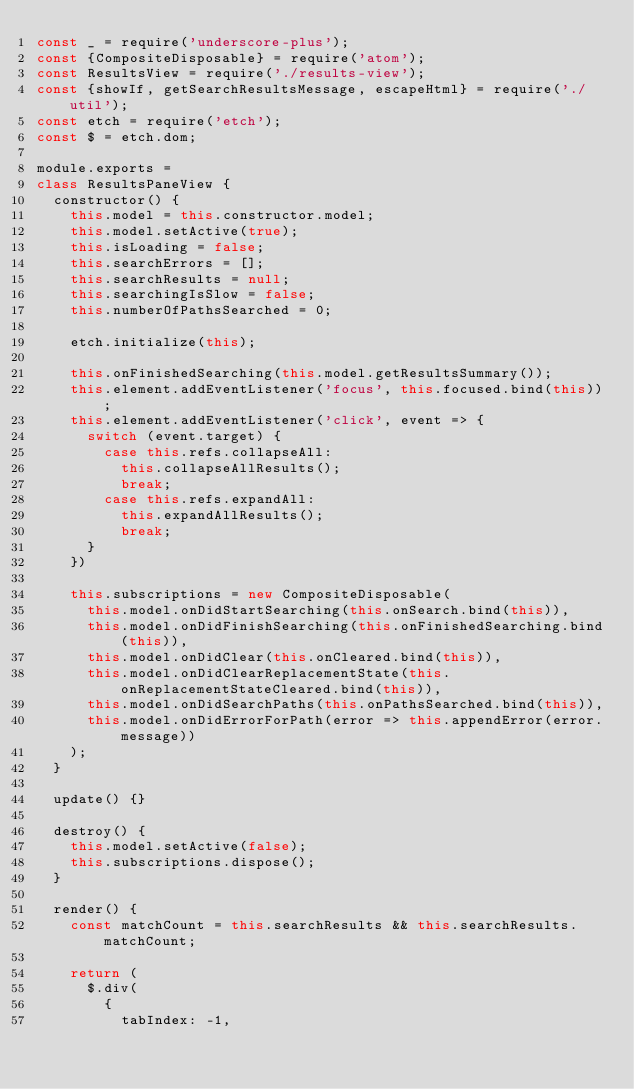Convert code to text. <code><loc_0><loc_0><loc_500><loc_500><_JavaScript_>const _ = require('underscore-plus');
const {CompositeDisposable} = require('atom');
const ResultsView = require('./results-view');
const {showIf, getSearchResultsMessage, escapeHtml} = require('./util');
const etch = require('etch');
const $ = etch.dom;

module.exports =
class ResultsPaneView {
  constructor() {
    this.model = this.constructor.model;
    this.model.setActive(true);
    this.isLoading = false;
    this.searchErrors = [];
    this.searchResults = null;
    this.searchingIsSlow = false;
    this.numberOfPathsSearched = 0;

    etch.initialize(this);

    this.onFinishedSearching(this.model.getResultsSummary());
    this.element.addEventListener('focus', this.focused.bind(this));
    this.element.addEventListener('click', event => {
      switch (event.target) {
        case this.refs.collapseAll:
          this.collapseAllResults();
          break;
        case this.refs.expandAll:
          this.expandAllResults();
          break;
      }
    })

    this.subscriptions = new CompositeDisposable(
      this.model.onDidStartSearching(this.onSearch.bind(this)),
      this.model.onDidFinishSearching(this.onFinishedSearching.bind(this)),
      this.model.onDidClear(this.onCleared.bind(this)),
      this.model.onDidClearReplacementState(this.onReplacementStateCleared.bind(this)),
      this.model.onDidSearchPaths(this.onPathsSearched.bind(this)),
      this.model.onDidErrorForPath(error => this.appendError(error.message))
    );
  }

  update() {}

  destroy() {
    this.model.setActive(false);
    this.subscriptions.dispose();
  }

  render() {
    const matchCount = this.searchResults && this.searchResults.matchCount;

    return (
      $.div(
        {
          tabIndex: -1,</code> 